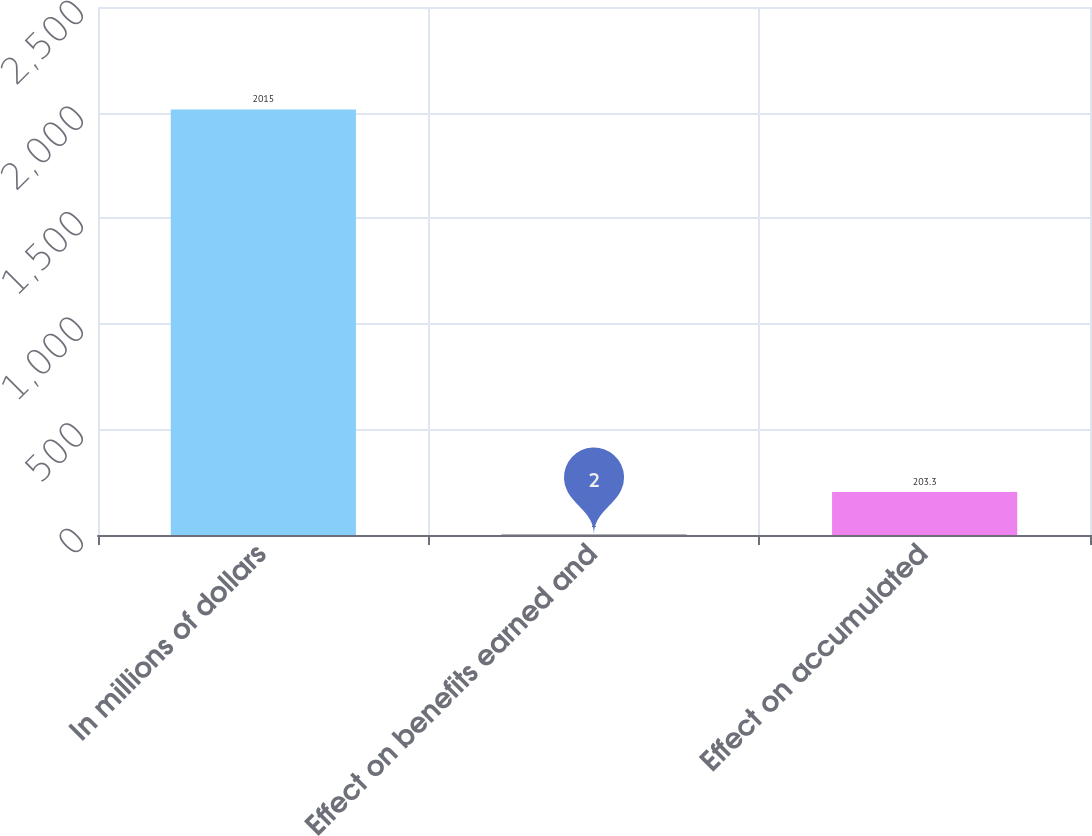Convert chart. <chart><loc_0><loc_0><loc_500><loc_500><bar_chart><fcel>In millions of dollars<fcel>Effect on benefits earned and<fcel>Effect on accumulated<nl><fcel>2015<fcel>2<fcel>203.3<nl></chart> 